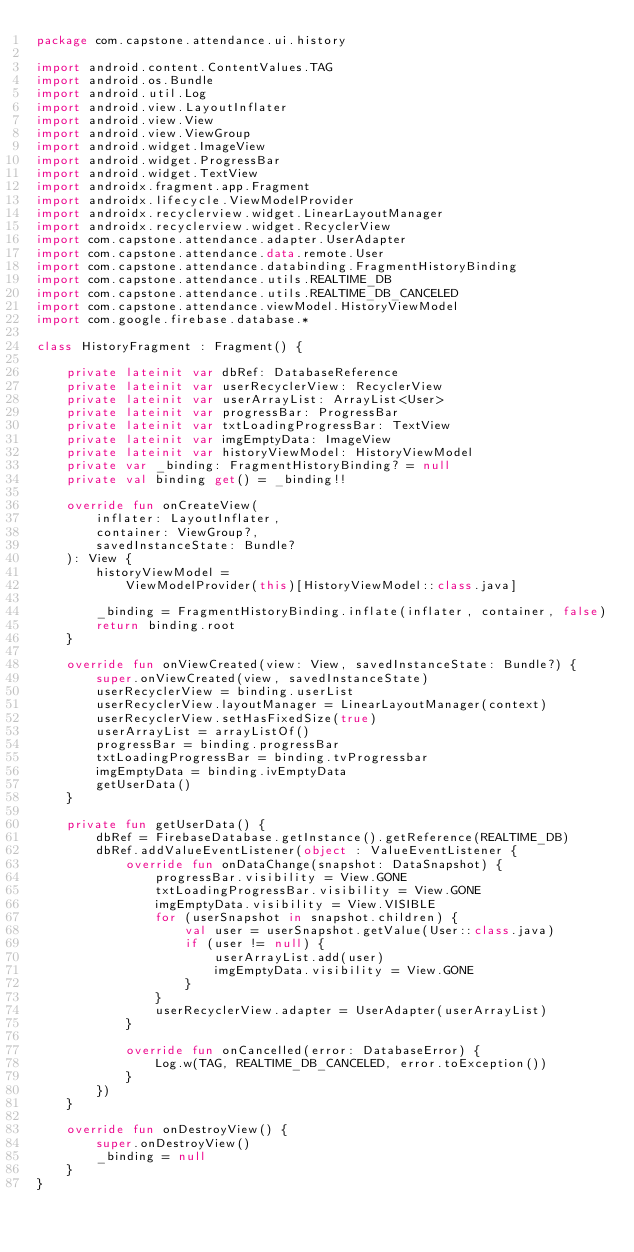<code> <loc_0><loc_0><loc_500><loc_500><_Kotlin_>package com.capstone.attendance.ui.history

import android.content.ContentValues.TAG
import android.os.Bundle
import android.util.Log
import android.view.LayoutInflater
import android.view.View
import android.view.ViewGroup
import android.widget.ImageView
import android.widget.ProgressBar
import android.widget.TextView
import androidx.fragment.app.Fragment
import androidx.lifecycle.ViewModelProvider
import androidx.recyclerview.widget.LinearLayoutManager
import androidx.recyclerview.widget.RecyclerView
import com.capstone.attendance.adapter.UserAdapter
import com.capstone.attendance.data.remote.User
import com.capstone.attendance.databinding.FragmentHistoryBinding
import com.capstone.attendance.utils.REALTIME_DB
import com.capstone.attendance.utils.REALTIME_DB_CANCELED
import com.capstone.attendance.viewModel.HistoryViewModel
import com.google.firebase.database.*

class HistoryFragment : Fragment() {

    private lateinit var dbRef: DatabaseReference
    private lateinit var userRecyclerView: RecyclerView
    private lateinit var userArrayList: ArrayList<User>
    private lateinit var progressBar: ProgressBar
    private lateinit var txtLoadingProgressBar: TextView
    private lateinit var imgEmptyData: ImageView
    private lateinit var historyViewModel: HistoryViewModel
    private var _binding: FragmentHistoryBinding? = null
    private val binding get() = _binding!!

    override fun onCreateView(
        inflater: LayoutInflater,
        container: ViewGroup?,
        savedInstanceState: Bundle?
    ): View {
        historyViewModel =
            ViewModelProvider(this)[HistoryViewModel::class.java]

        _binding = FragmentHistoryBinding.inflate(inflater, container, false)
        return binding.root
    }

    override fun onViewCreated(view: View, savedInstanceState: Bundle?) {
        super.onViewCreated(view, savedInstanceState)
        userRecyclerView = binding.userList
        userRecyclerView.layoutManager = LinearLayoutManager(context)
        userRecyclerView.setHasFixedSize(true)
        userArrayList = arrayListOf()
        progressBar = binding.progressBar
        txtLoadingProgressBar = binding.tvProgressbar
        imgEmptyData = binding.ivEmptyData
        getUserData()
    }

    private fun getUserData() {
        dbRef = FirebaseDatabase.getInstance().getReference(REALTIME_DB)
        dbRef.addValueEventListener(object : ValueEventListener {
            override fun onDataChange(snapshot: DataSnapshot) {
                progressBar.visibility = View.GONE
                txtLoadingProgressBar.visibility = View.GONE
                imgEmptyData.visibility = View.VISIBLE
                for (userSnapshot in snapshot.children) {
                    val user = userSnapshot.getValue(User::class.java)
                    if (user != null) {
                        userArrayList.add(user)
                        imgEmptyData.visibility = View.GONE
                    }
                }
                userRecyclerView.adapter = UserAdapter(userArrayList)
            }

            override fun onCancelled(error: DatabaseError) {
                Log.w(TAG, REALTIME_DB_CANCELED, error.toException())
            }
        })
    }

    override fun onDestroyView() {
        super.onDestroyView()
        _binding = null
    }
}</code> 